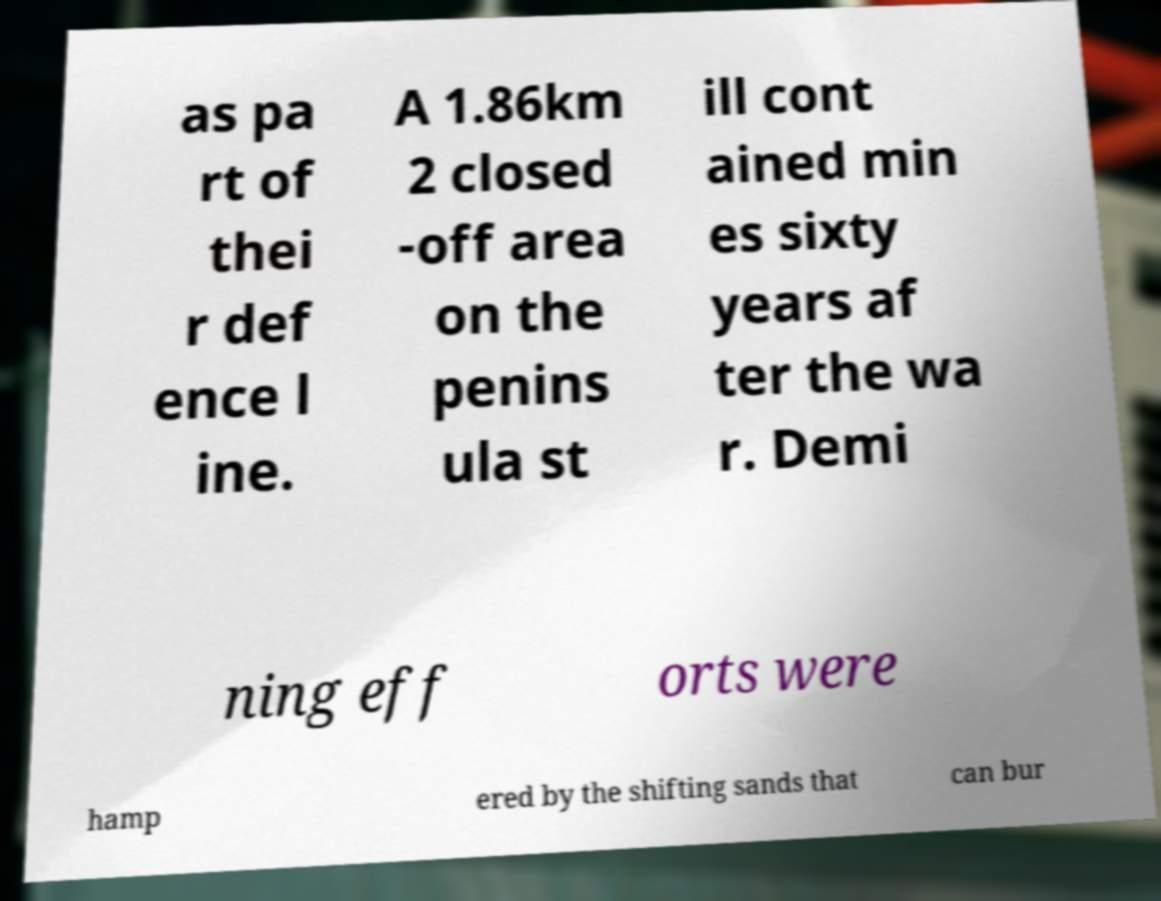Could you assist in decoding the text presented in this image and type it out clearly? as pa rt of thei r def ence l ine. A 1.86km 2 closed -off area on the penins ula st ill cont ained min es sixty years af ter the wa r. Demi ning eff orts were hamp ered by the shifting sands that can bur 